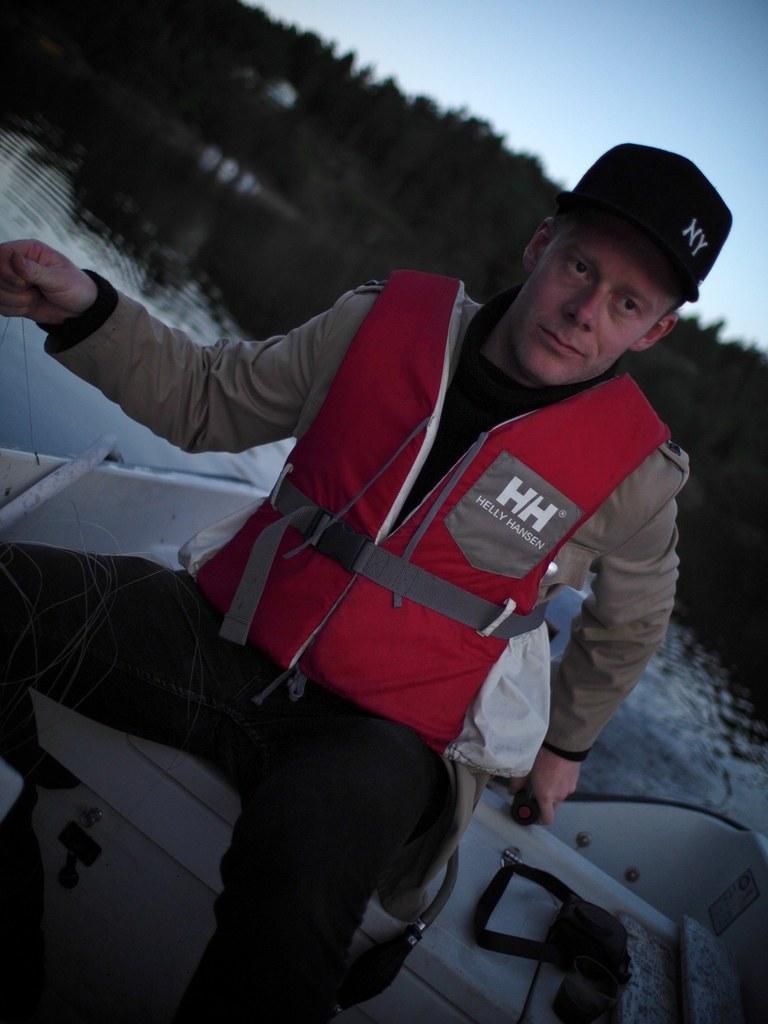Describe this image in one or two sentences. Here I can see a man wearing a jacket and sitting on the boat. In the background I can see the water and many trees. At the top of the image I can see the sky. 